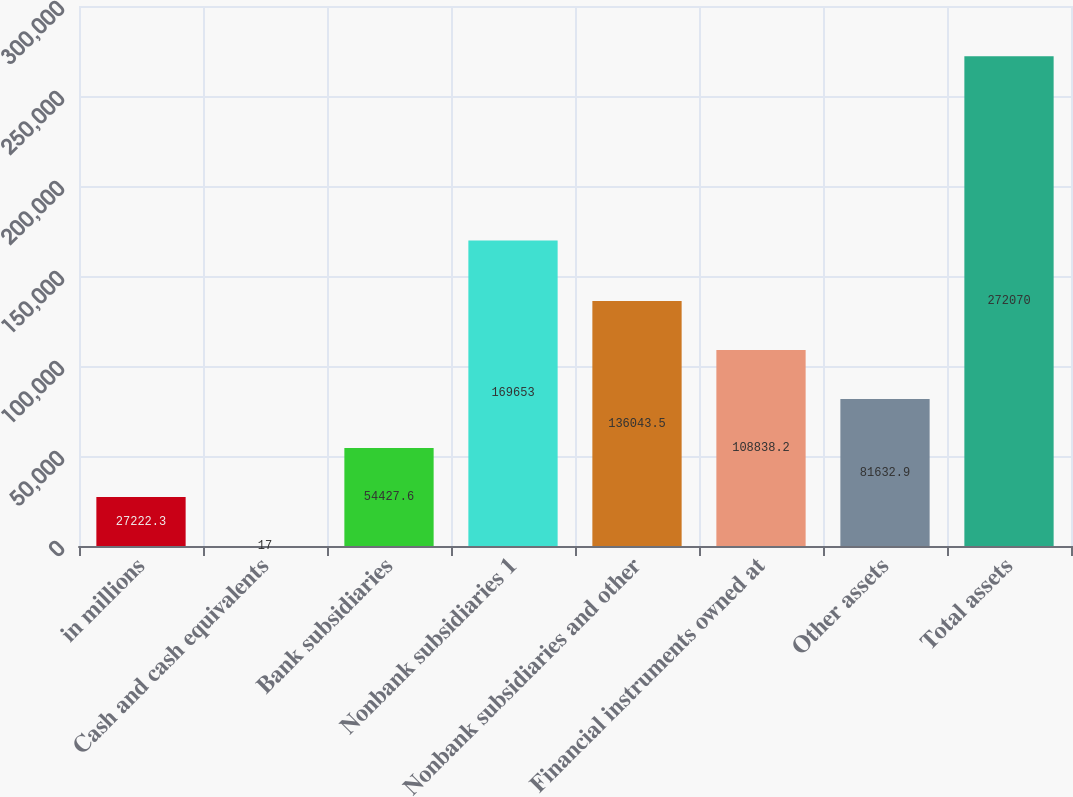Convert chart to OTSL. <chart><loc_0><loc_0><loc_500><loc_500><bar_chart><fcel>in millions<fcel>Cash and cash equivalents<fcel>Bank subsidiaries<fcel>Nonbank subsidiaries 1<fcel>Nonbank subsidiaries and other<fcel>Financial instruments owned at<fcel>Other assets<fcel>Total assets<nl><fcel>27222.3<fcel>17<fcel>54427.6<fcel>169653<fcel>136044<fcel>108838<fcel>81632.9<fcel>272070<nl></chart> 